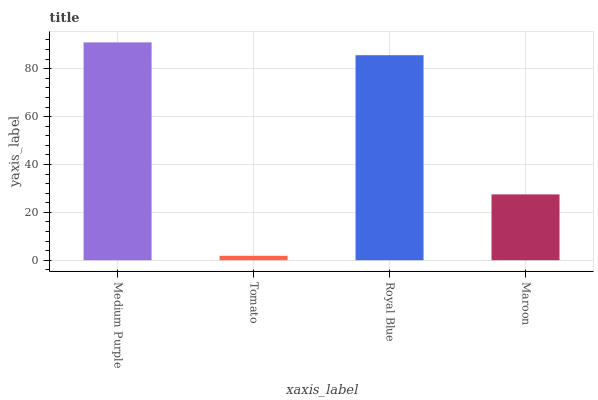Is Tomato the minimum?
Answer yes or no. Yes. Is Medium Purple the maximum?
Answer yes or no. Yes. Is Royal Blue the minimum?
Answer yes or no. No. Is Royal Blue the maximum?
Answer yes or no. No. Is Royal Blue greater than Tomato?
Answer yes or no. Yes. Is Tomato less than Royal Blue?
Answer yes or no. Yes. Is Tomato greater than Royal Blue?
Answer yes or no. No. Is Royal Blue less than Tomato?
Answer yes or no. No. Is Royal Blue the high median?
Answer yes or no. Yes. Is Maroon the low median?
Answer yes or no. Yes. Is Maroon the high median?
Answer yes or no. No. Is Medium Purple the low median?
Answer yes or no. No. 